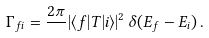<formula> <loc_0><loc_0><loc_500><loc_500>\Gamma _ { f i } = \frac { 2 \pi } { } | \langle f | T | i \rangle | ^ { 2 } \, \delta ( E _ { f } - E _ { i } ) \, .</formula> 